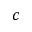<formula> <loc_0><loc_0><loc_500><loc_500>c</formula> 